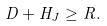<formula> <loc_0><loc_0><loc_500><loc_500>D + H _ { J } \geq R .</formula> 